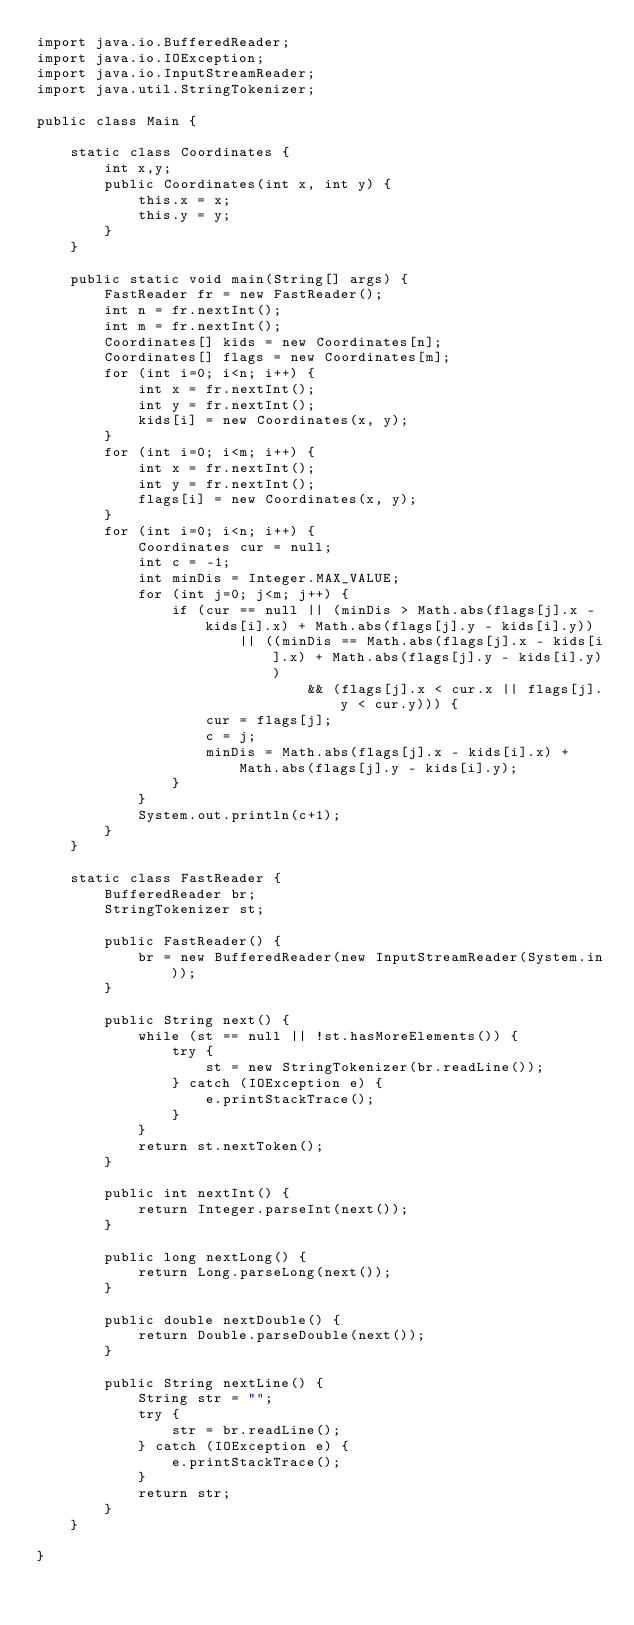<code> <loc_0><loc_0><loc_500><loc_500><_Java_>import java.io.BufferedReader;
import java.io.IOException;
import java.io.InputStreamReader;
import java.util.StringTokenizer;

public class Main {
	
	static class Coordinates {
		int x,y;
		public Coordinates(int x, int y) {
			this.x = x;
			this.y = y;
		}
	}

	public static void main(String[] args) {
		FastReader fr = new FastReader();
		int n = fr.nextInt();
		int m = fr.nextInt();
		Coordinates[] kids = new Coordinates[n];
		Coordinates[] flags = new Coordinates[m];
		for (int i=0; i<n; i++) {
			int x = fr.nextInt();
			int y = fr.nextInt();
			kids[i] = new Coordinates(x, y);
		}
		for (int i=0; i<m; i++) {
			int x = fr.nextInt();
			int y = fr.nextInt();
			flags[i] = new Coordinates(x, y);
		}
		for (int i=0; i<n; i++) {
			Coordinates cur = null;
			int c = -1;
			int minDis = Integer.MAX_VALUE;
			for (int j=0; j<m; j++) {
				if (cur == null || (minDis > Math.abs(flags[j].x - kids[i].x) + Math.abs(flags[j].y - kids[i].y))
						|| ((minDis == Math.abs(flags[j].x - kids[i].x) + Math.abs(flags[j].y - kids[i].y)) 
								&& (flags[j].x < cur.x || flags[j].y < cur.y))) {
					cur = flags[j];
					c = j;
					minDis = Math.abs(flags[j].x - kids[i].x) + Math.abs(flags[j].y - kids[i].y);
				}
			}
			System.out.println(c+1);
		}
	}
	
	static class FastReader {
		BufferedReader br;
		StringTokenizer st;

		public FastReader() {
			br = new BufferedReader(new InputStreamReader(System.in));
		}

		public String next() {
			while (st == null || !st.hasMoreElements()) {
				try {
					st = new StringTokenizer(br.readLine());
				} catch (IOException e) {
					e.printStackTrace();
				}
			}
			return st.nextToken();
		}

		public int nextInt() {
			return Integer.parseInt(next());
		}

		public long nextLong() {
			return Long.parseLong(next());
		}

		public double nextDouble() {
			return Double.parseDouble(next());
		}

		public String nextLine() {
			String str = "";
			try {
				str = br.readLine();
			} catch (IOException e) {
				e.printStackTrace();
			}
			return str;
		}
	}

}
</code> 